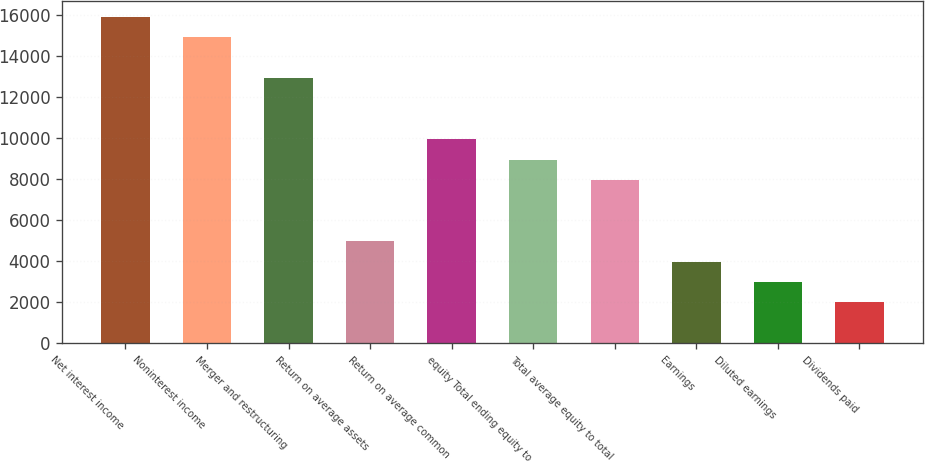Convert chart to OTSL. <chart><loc_0><loc_0><loc_500><loc_500><bar_chart><fcel>Net interest income<fcel>Noninterest income<fcel>Merger and restructuring<fcel>Return on average assets<fcel>Return on average common<fcel>equity Total ending equity to<fcel>Total average equity to total<fcel>Earnings<fcel>Diluted earnings<fcel>Dividends paid<nl><fcel>15883<fcel>14890.3<fcel>12905<fcel>4963.7<fcel>9927<fcel>8934.34<fcel>7941.68<fcel>3971.04<fcel>2978.38<fcel>1985.72<nl></chart> 